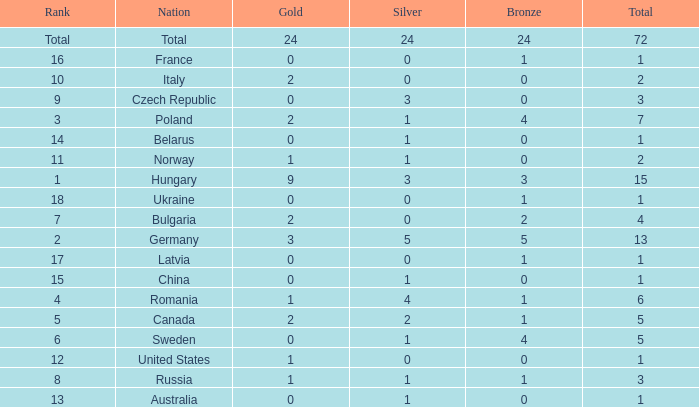What average total has 0 as the gold, with 6 as the rank? 5.0. 